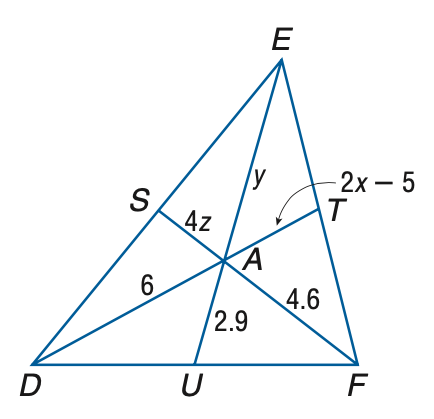Answer the mathemtical geometry problem and directly provide the correct option letter.
Question: Points S, T, and U are the midpoints of D E, E F, and D F, respectively. Find x.
Choices: A: 4 B: 4.5 C: 5 D: 5.5 A 